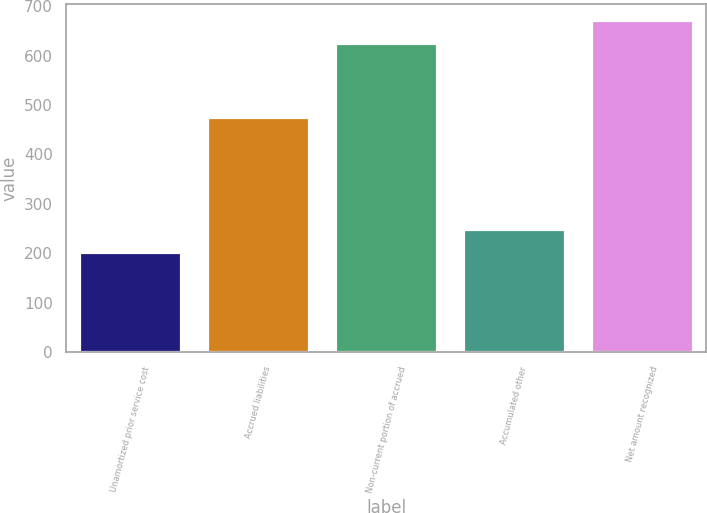Convert chart to OTSL. <chart><loc_0><loc_0><loc_500><loc_500><bar_chart><fcel>Unamortized prior service cost<fcel>Accrued liabilities<fcel>Non-current portion of accrued<fcel>Accumulated other<fcel>Net amount recognized<nl><fcel>203<fcel>475<fcel>625<fcel>249.5<fcel>671.5<nl></chart> 